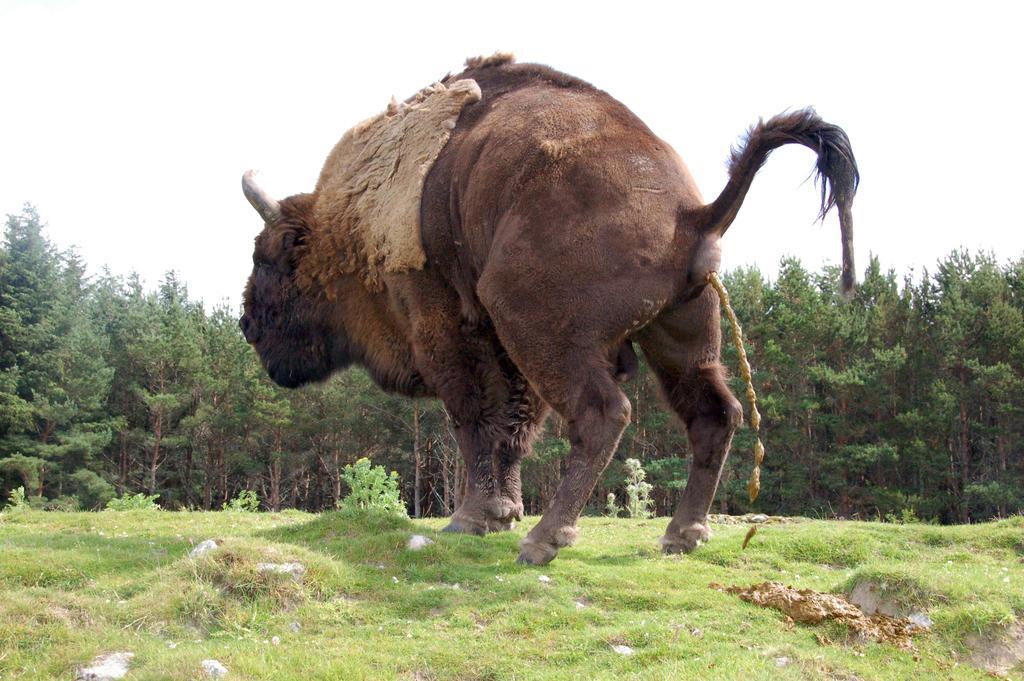How would you summarize this image in a sentence or two? As we can see in the image, in the front there is a animal standing on grass. Behind the animal there are lot of trees. On the top there is a sky. 